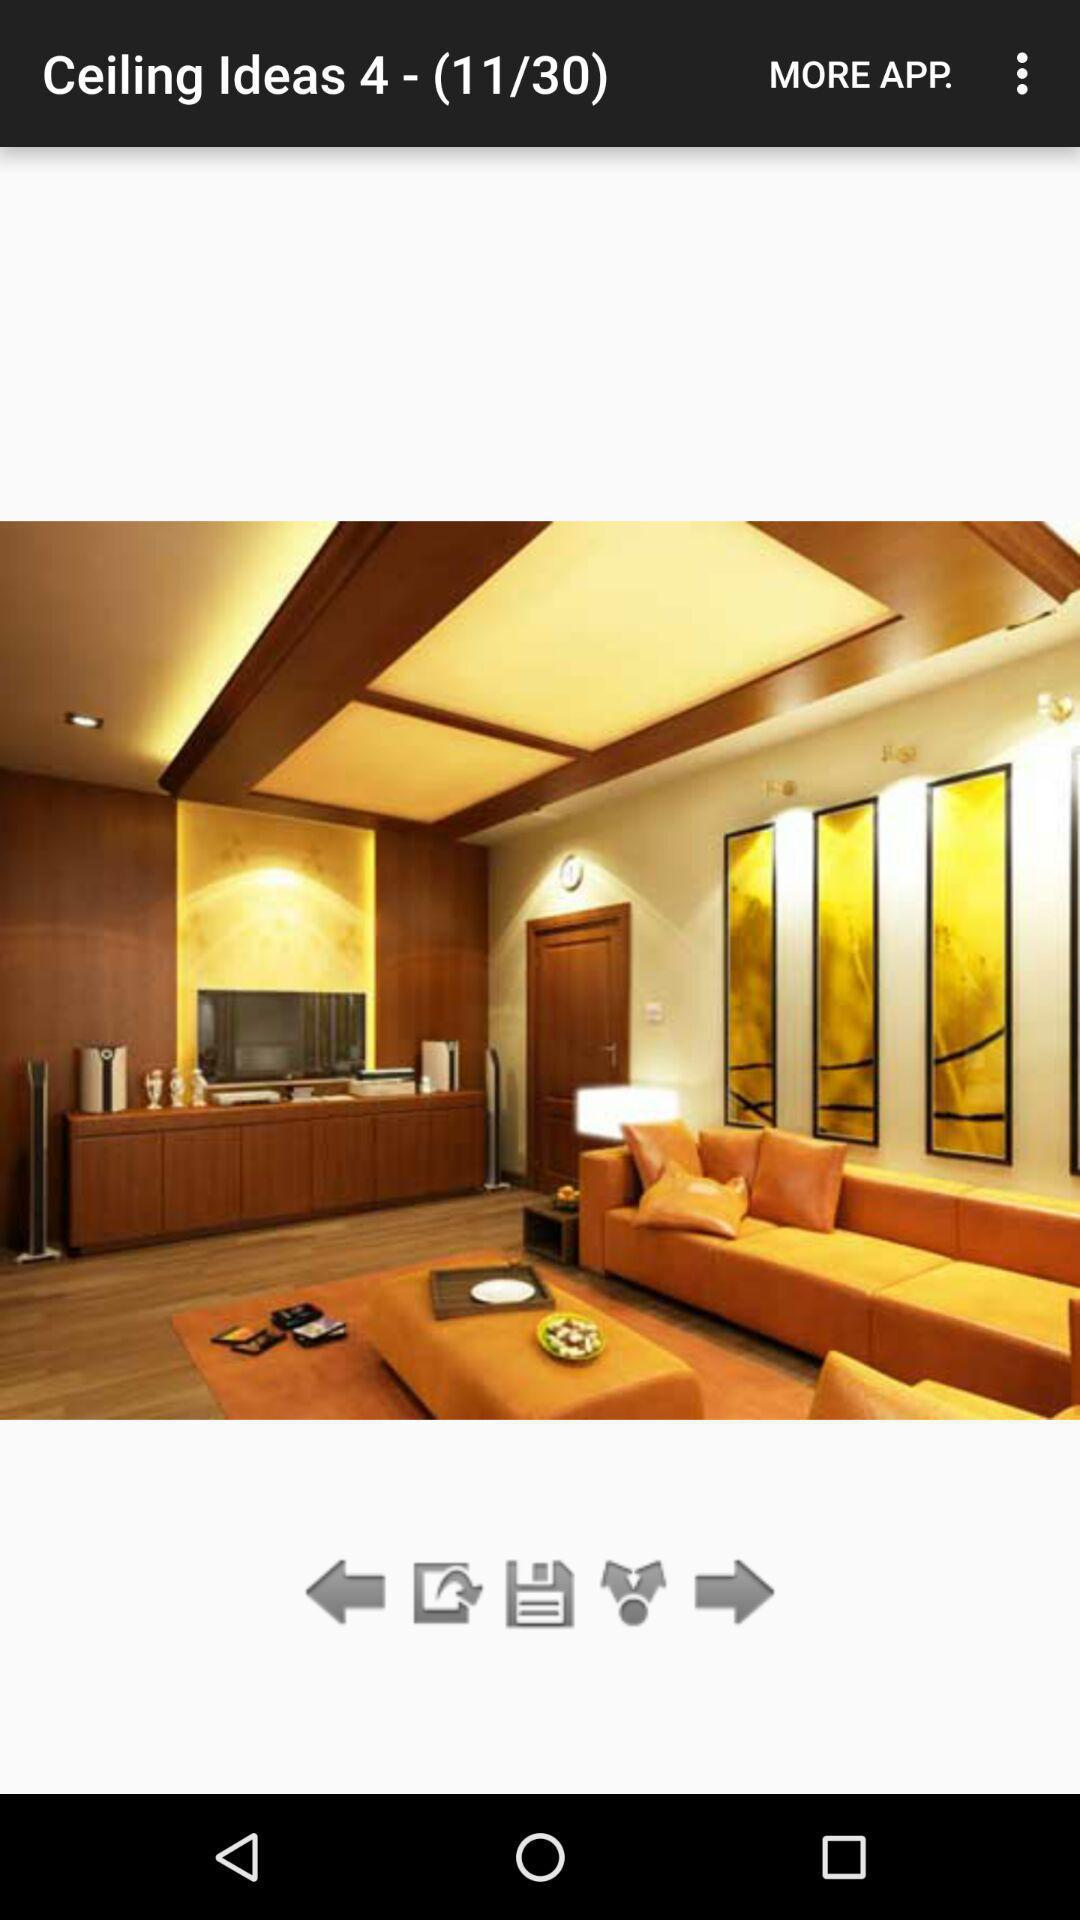Which image number are we currently on? You are currently on the 11th image. 